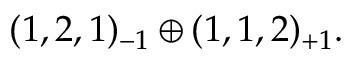<formula> <loc_0><loc_0><loc_500><loc_500>( 1 , 2 , 1 ) _ { - 1 } \oplus ( 1 , 1 , 2 ) _ { + 1 } .</formula> 